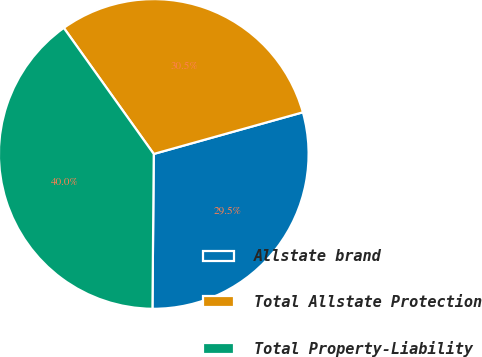Convert chart. <chart><loc_0><loc_0><loc_500><loc_500><pie_chart><fcel>Allstate brand<fcel>Total Allstate Protection<fcel>Total Property-Liability<nl><fcel>29.47%<fcel>30.53%<fcel>40.0%<nl></chart> 